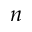Convert formula to latex. <formula><loc_0><loc_0><loc_500><loc_500>n</formula> 